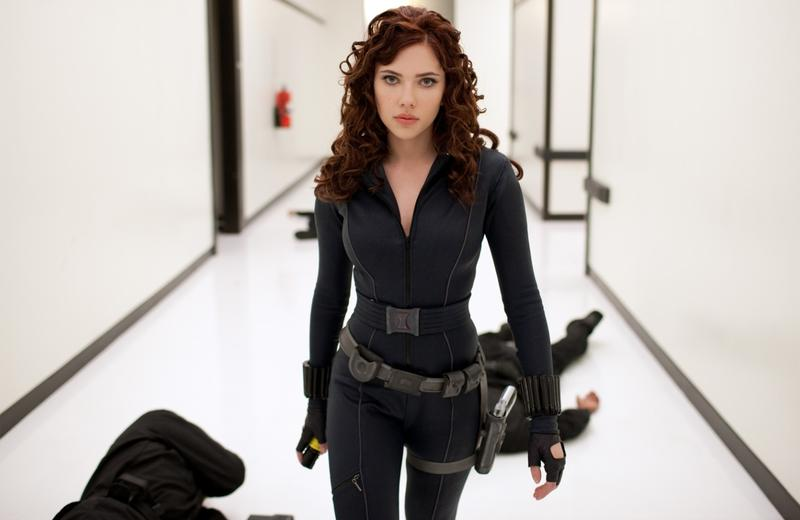Write a detailed account from the character’s perspective. As I walked down the stark white hallway, the silence was broken by the sound of my boots against the polished floor. The aftermath of my recent confrontation lay behind me, two adversaries now subdued, their motions finally stilled. My black jumpsuit, equipped with holsters and weapons, felt like both armor and weight, a constant reminder of my mission. Each step was deliberate, each breath measured, as I focused on what lies ahead. The corridor seemed endless, the perspective lines on the walls and floor stretching out, almost merging in the distance. My fingers itched for my weapons, ready for whatever came next. The stakes were high, and I couldn't afford to be distracted. Despite the soft curls of my hair brushing against my face, there was nothing but steel in my expression. In that moment of intense focus, I reminded myself: I am Black Widow. And this war is far from over. 